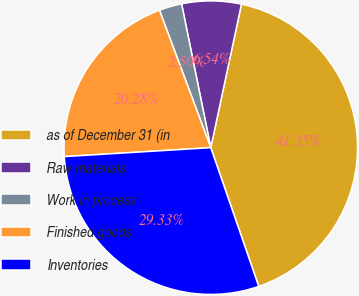Convert chart. <chart><loc_0><loc_0><loc_500><loc_500><pie_chart><fcel>as of December 31 (in<fcel>Raw materials<fcel>Work in process<fcel>Finished goods<fcel>Inventories<nl><fcel>41.35%<fcel>6.54%<fcel>2.5%<fcel>20.28%<fcel>29.33%<nl></chart> 